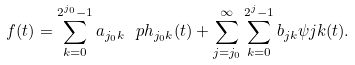<formula> <loc_0><loc_0><loc_500><loc_500>f ( t ) = \sum _ { k = 0 } ^ { 2 ^ { j _ { 0 } } - 1 } a _ { j _ { 0 } k } \ p h _ { j _ { 0 } k } ( t ) + \sum _ { j = j _ { 0 } } ^ { \infty } \sum _ { k = 0 } ^ { 2 ^ { j } - 1 } b _ { j k } \psi j k ( t ) .</formula> 